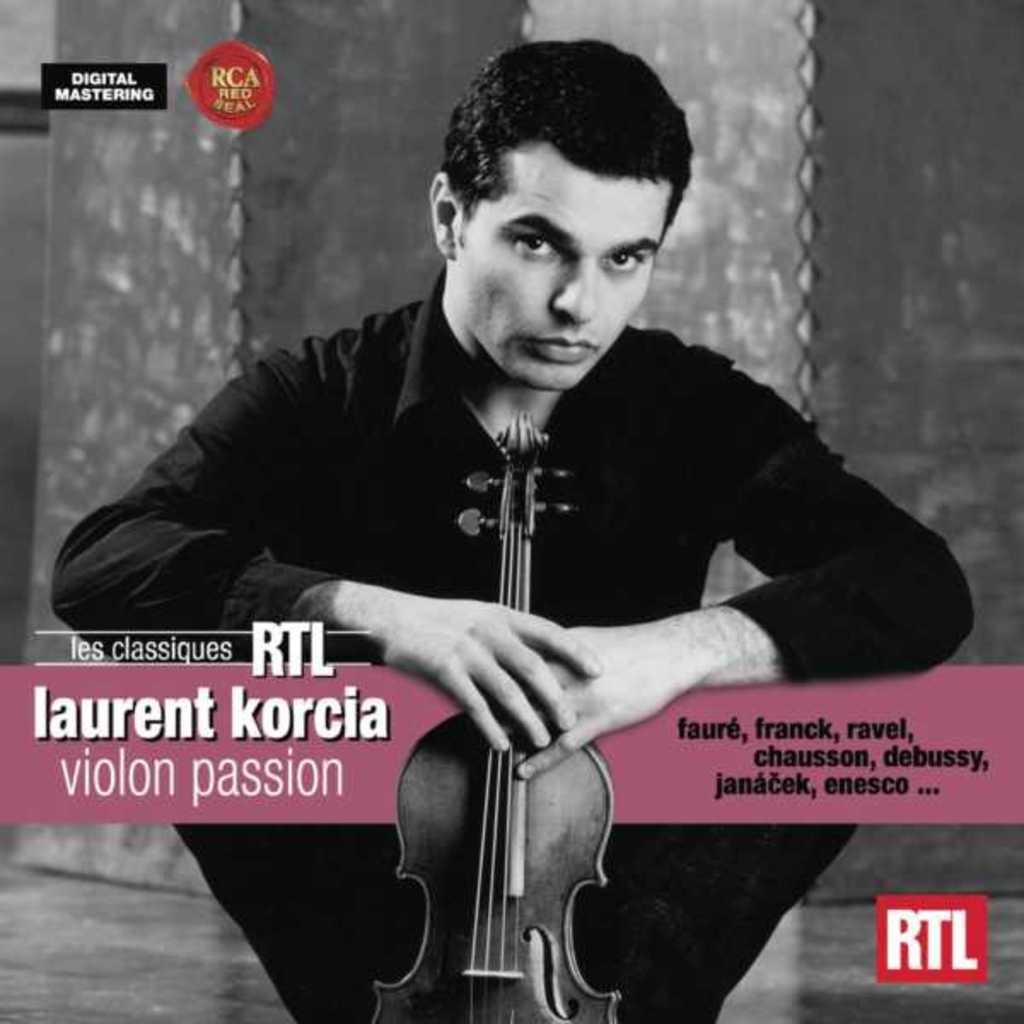What is the color scheme of the image? The image is black and white. What is the man in the image doing? The man is sitting on the floor in the image. What object is the man holding in the image? The man is holding a guitar in the image. How much money is the man holding in the image? There is no money visible in the image; the man is holding a guitar. What type of cap is the man wearing in the image? The man is not wearing a cap in the image; he is holding a guitar. 